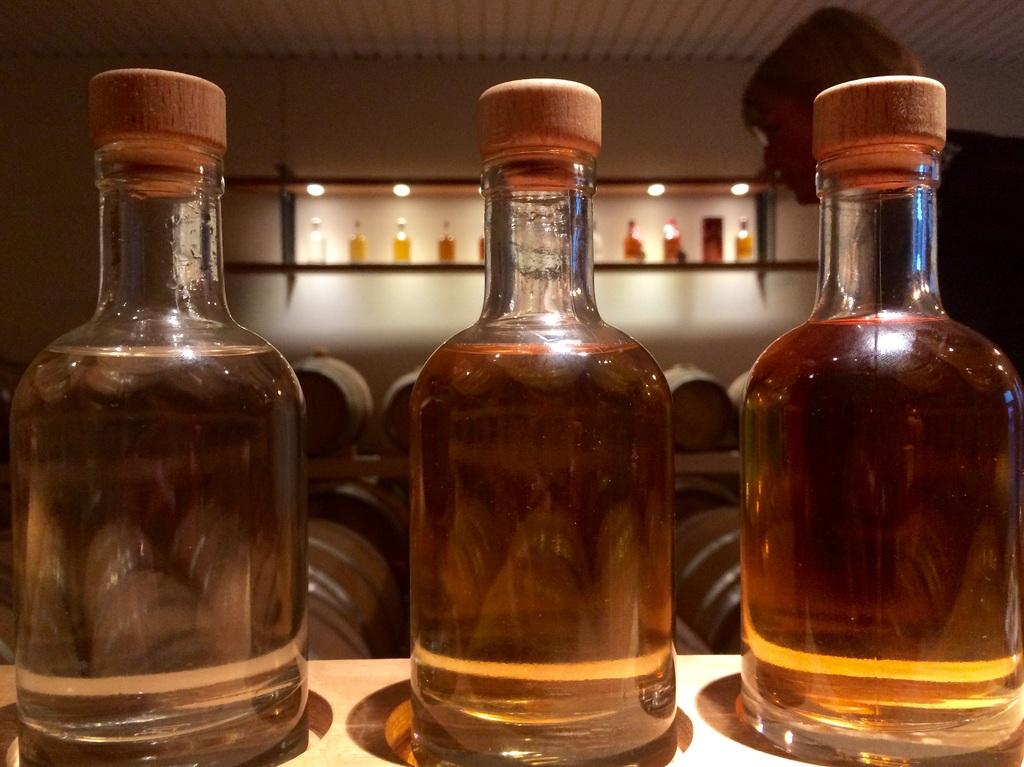How many wine bottles are visible in the image? There are three wine bottles in the image. What is located to the right of the wine bottles? There is a person to the right of the wine bottles. What can be seen in the background of the image? There are lights and wine bottles in a rack in the background of the image. What type of cheese is being used in the stomach apparatus in the image? There is no cheese or stomach apparatus present in the image. 